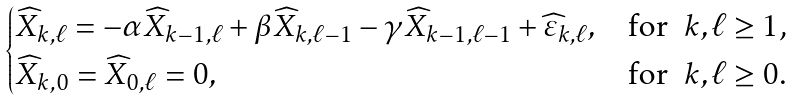Convert formula to latex. <formula><loc_0><loc_0><loc_500><loc_500>\begin{cases} \widehat { X } _ { k , \ell } = - \alpha \widehat { X } _ { k - 1 , \ell } + \beta \widehat { X } _ { k , \ell - 1 } - \gamma \widehat { X } _ { k - 1 , \ell - 1 } + \widehat { \varepsilon } _ { k , \ell } , & \text {for \ $k,\ell \geq 1$,} \\ \widehat { X } _ { k , 0 } = \widehat { X } _ { 0 , \ell } = 0 , & \text {for \ $k,\ell\geq0$.} \end{cases}</formula> 